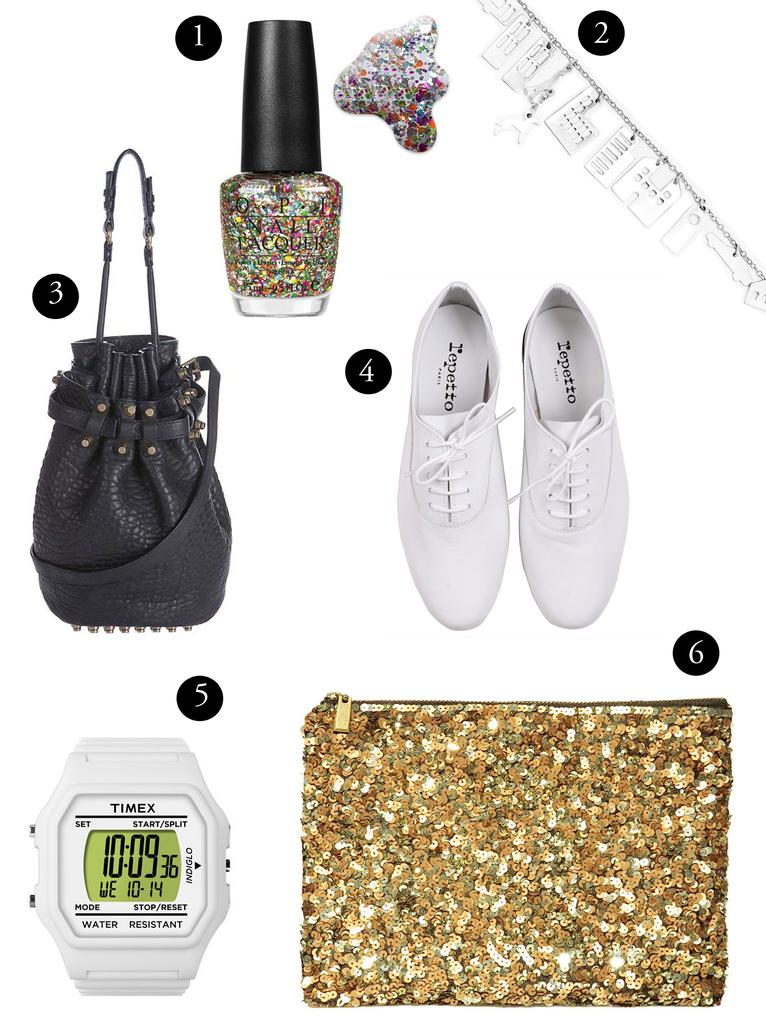<image>
Offer a succinct explanation of the picture presented. A numbered selection of accessories and apparel are on a white background. 